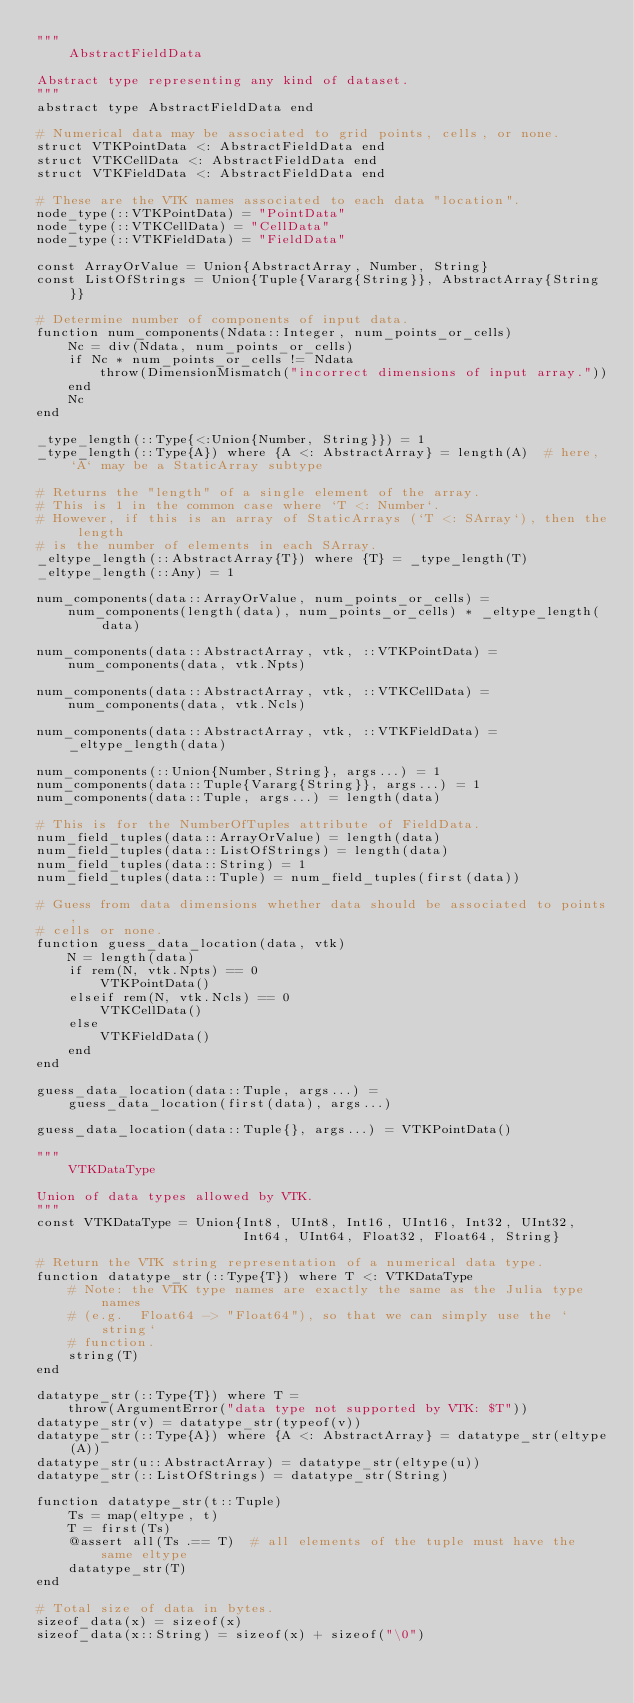Convert code to text. <code><loc_0><loc_0><loc_500><loc_500><_Julia_>"""
    AbstractFieldData

Abstract type representing any kind of dataset.
"""
abstract type AbstractFieldData end

# Numerical data may be associated to grid points, cells, or none.
struct VTKPointData <: AbstractFieldData end
struct VTKCellData <: AbstractFieldData end
struct VTKFieldData <: AbstractFieldData end

# These are the VTK names associated to each data "location".
node_type(::VTKPointData) = "PointData"
node_type(::VTKCellData) = "CellData"
node_type(::VTKFieldData) = "FieldData"

const ArrayOrValue = Union{AbstractArray, Number, String}
const ListOfStrings = Union{Tuple{Vararg{String}}, AbstractArray{String}}

# Determine number of components of input data.
function num_components(Ndata::Integer, num_points_or_cells)
    Nc = div(Ndata, num_points_or_cells)
    if Nc * num_points_or_cells != Ndata
        throw(DimensionMismatch("incorrect dimensions of input array."))
    end
    Nc
end

_type_length(::Type{<:Union{Number, String}}) = 1
_type_length(::Type{A}) where {A <: AbstractArray} = length(A)  # here, `A` may be a StaticArray subtype

# Returns the "length" of a single element of the array.
# This is 1 in the common case where `T <: Number`.
# However, if this is an array of StaticArrays (`T <: SArray`), then the length
# is the number of elements in each SArray.
_eltype_length(::AbstractArray{T}) where {T} = _type_length(T)
_eltype_length(::Any) = 1

num_components(data::ArrayOrValue, num_points_or_cells) =
    num_components(length(data), num_points_or_cells) * _eltype_length(data)

num_components(data::AbstractArray, vtk, ::VTKPointData) =
    num_components(data, vtk.Npts)

num_components(data::AbstractArray, vtk, ::VTKCellData) =
    num_components(data, vtk.Ncls)

num_components(data::AbstractArray, vtk, ::VTKFieldData) =
    _eltype_length(data)

num_components(::Union{Number,String}, args...) = 1
num_components(data::Tuple{Vararg{String}}, args...) = 1
num_components(data::Tuple, args...) = length(data)

# This is for the NumberOfTuples attribute of FieldData.
num_field_tuples(data::ArrayOrValue) = length(data)
num_field_tuples(data::ListOfStrings) = length(data)
num_field_tuples(data::String) = 1
num_field_tuples(data::Tuple) = num_field_tuples(first(data))

# Guess from data dimensions whether data should be associated to points,
# cells or none.
function guess_data_location(data, vtk)
    N = length(data)
    if rem(N, vtk.Npts) == 0
        VTKPointData()
    elseif rem(N, vtk.Ncls) == 0
        VTKCellData()
    else
        VTKFieldData()
    end
end

guess_data_location(data::Tuple, args...) =
    guess_data_location(first(data), args...)

guess_data_location(data::Tuple{}, args...) = VTKPointData()

"""
    VTKDataType

Union of data types allowed by VTK.
"""
const VTKDataType = Union{Int8, UInt8, Int16, UInt16, Int32, UInt32,
                          Int64, UInt64, Float32, Float64, String}

# Return the VTK string representation of a numerical data type.
function datatype_str(::Type{T}) where T <: VTKDataType
    # Note: the VTK type names are exactly the same as the Julia type names
    # (e.g.  Float64 -> "Float64"), so that we can simply use the `string`
    # function.
    string(T)
end

datatype_str(::Type{T}) where T =
    throw(ArgumentError("data type not supported by VTK: $T"))
datatype_str(v) = datatype_str(typeof(v))
datatype_str(::Type{A}) where {A <: AbstractArray} = datatype_str(eltype(A))
datatype_str(u::AbstractArray) = datatype_str(eltype(u))
datatype_str(::ListOfStrings) = datatype_str(String)

function datatype_str(t::Tuple)
    Ts = map(eltype, t)
    T = first(Ts)
    @assert all(Ts .== T)  # all elements of the tuple must have the same eltype
    datatype_str(T)
end

# Total size of data in bytes.
sizeof_data(x) = sizeof(x)
sizeof_data(x::String) = sizeof(x) + sizeof("\0")</code> 